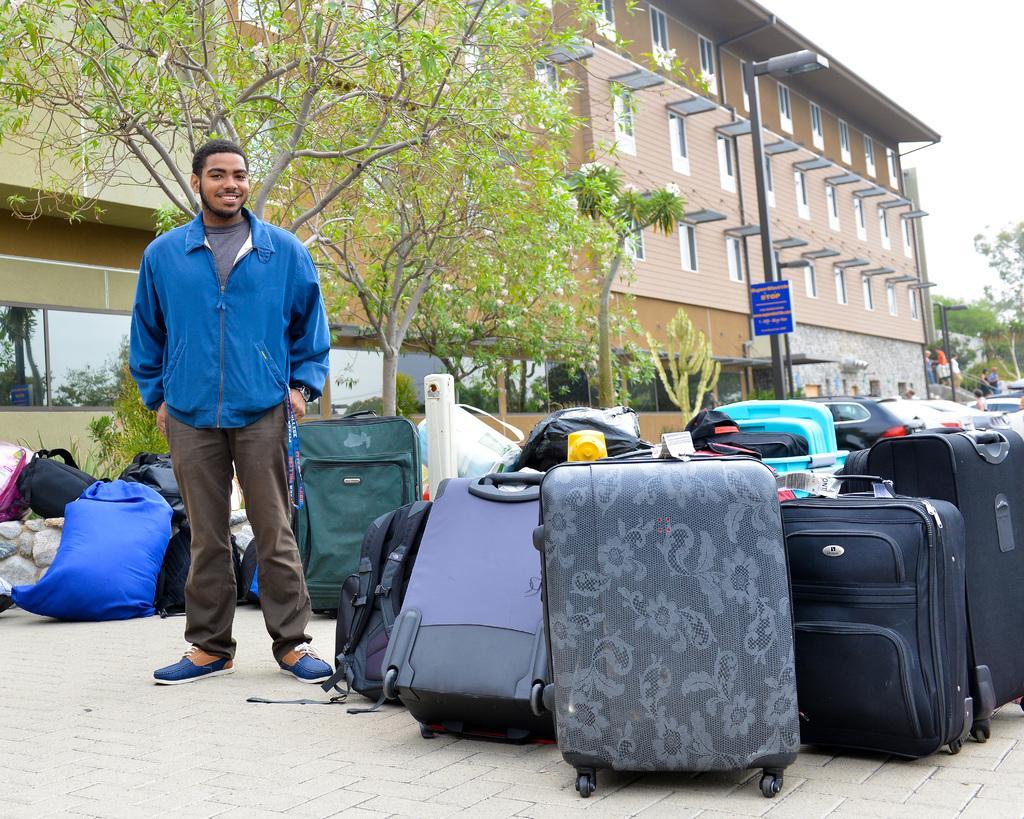Describe this image in one or two sentences. In this image there is one person who is standing and he is wearing a blue jacket and he is smiling and, on the right side and left side there are some luggage and backpacks. Behind that person there is one tree, and on the right side of the image there is one building and on the left side also there is another building. In the middle of the image there are some windows of glass, and in the middle of the image there is one pole and street light and one board is attached to that pole. And in the left side there are some trees and sky. 